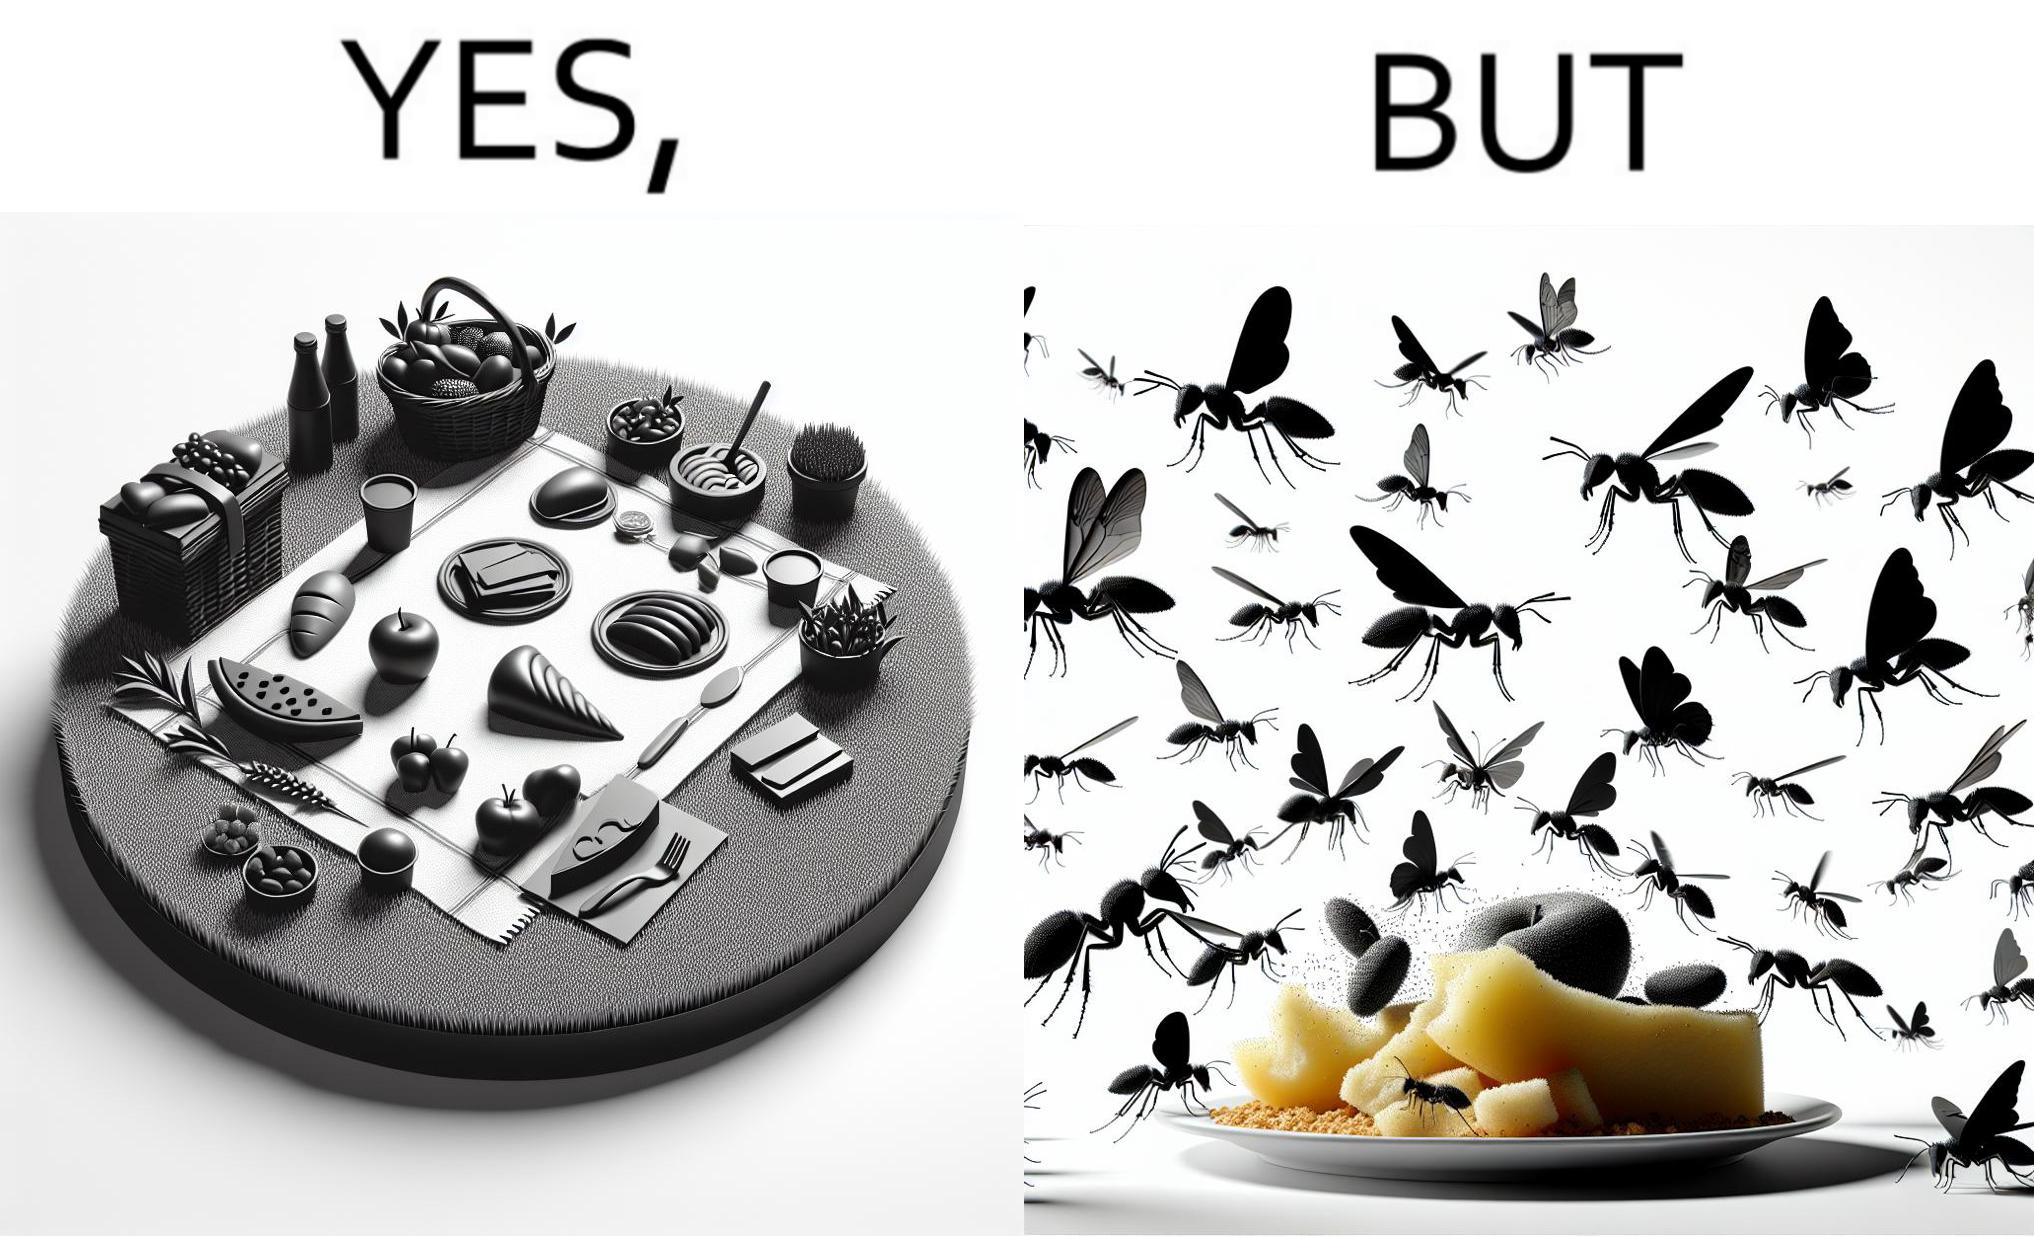What makes this image funny or satirical? The Picture shows that although we enjoy food in garden but there are some consequences of eating food in garden. Many bugs and bees are attracted towards our food and make our food sometimes non-eatable. 